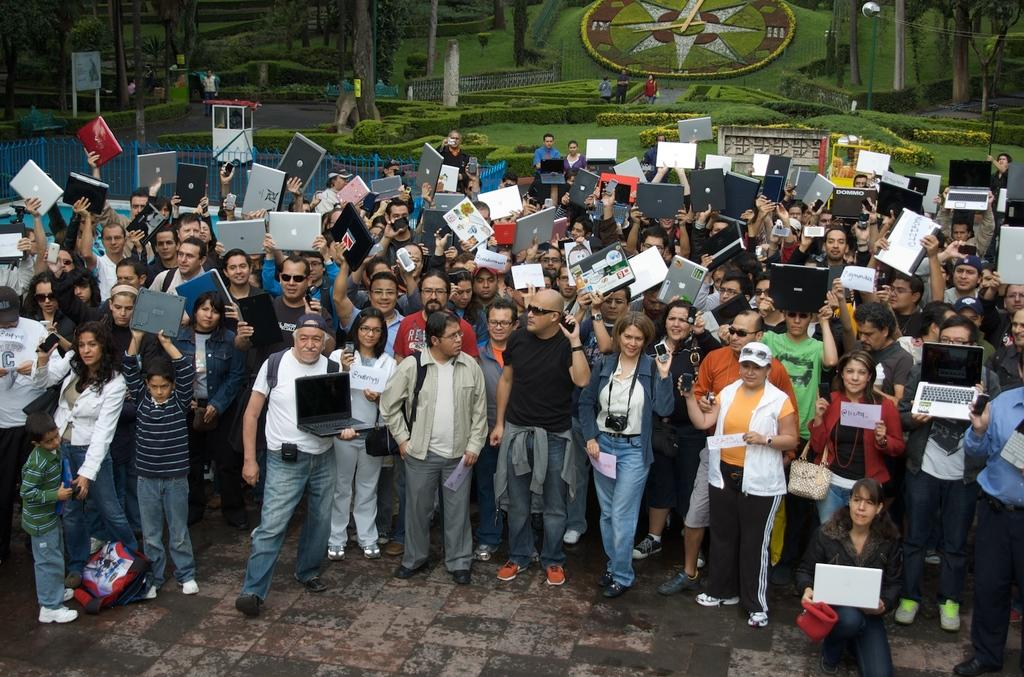How many people are in the image? There is a group of people standing in the image. What is the surface on which the people are standing? The people are standing on the floor. What electronic devices can be seen in the image? There are laptops and cameras in the image. What items are present for carrying belongings? There are bags in the image. What type of structure is visible in the image? There is a booth in the image. What is the purpose of the board in the image? The purpose of the board in the image is not specified, but it may be used for displaying information or as a surface for writing or drawing. What can be seen in the background of the image? There are trees in the background of the image. How many cats are visible on the laptops in the image? There are no cats present on the laptops or anywhere else in the image. 